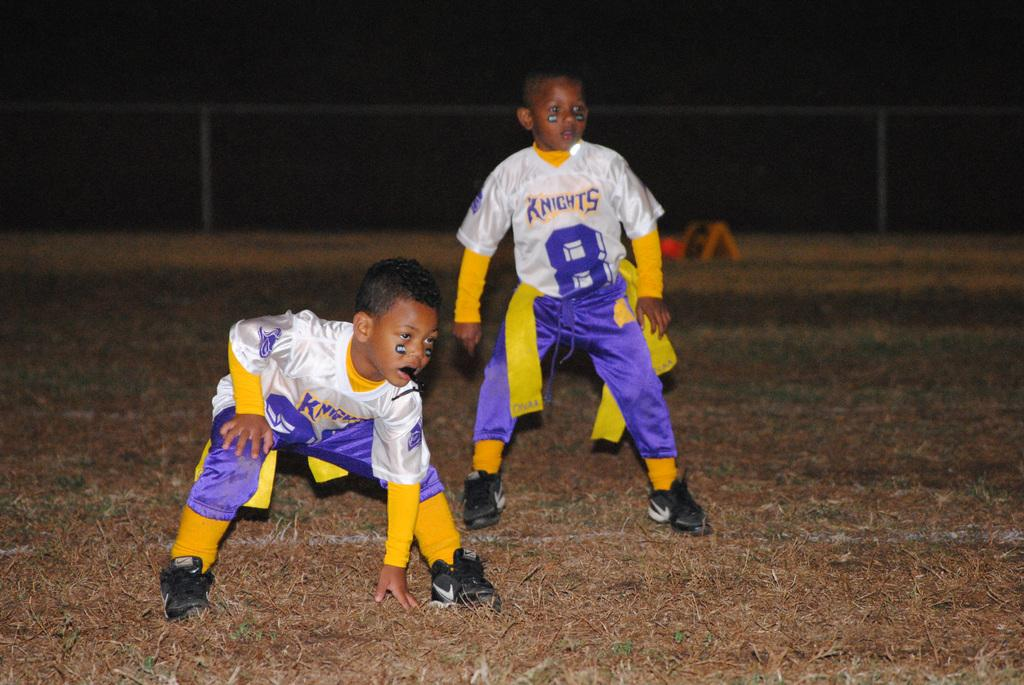<image>
Create a compact narrative representing the image presented. Two young boys playing football for the Knights in purple, white and yellow uniforms. 